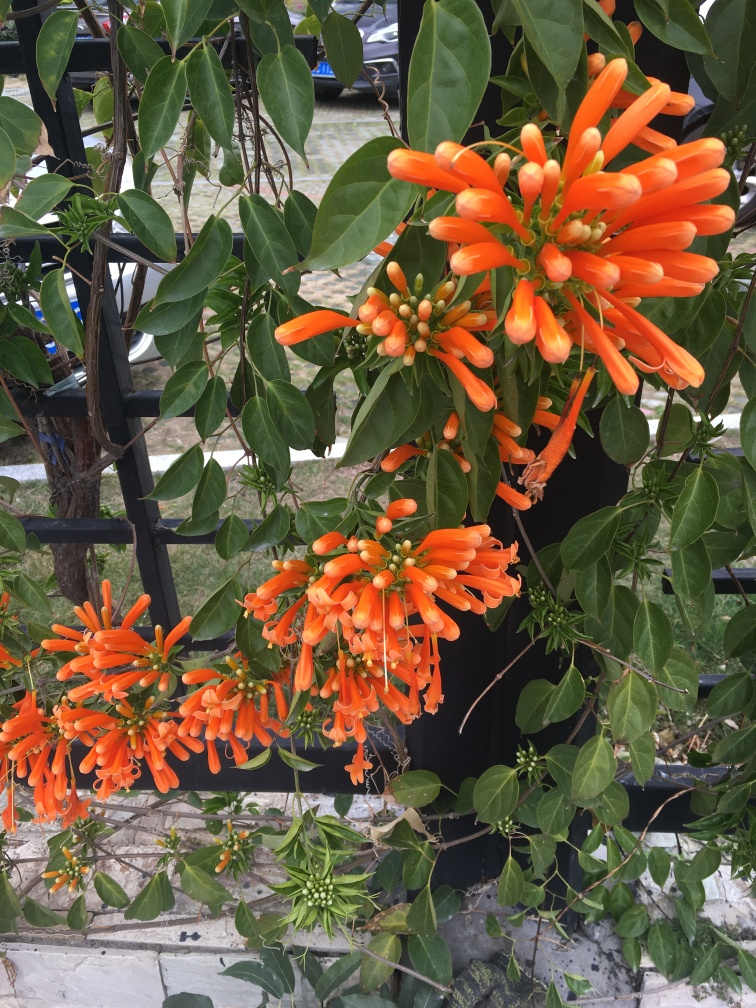Can you tell me what type of flowers these are? These appear to be Pyrostegia venusta, also known as flame vine or orange trumpet vine, which is known for its vivid orange flowers that grow in clusters. Are these flowers common in certain areas or climates? Yes, Pyrostegia venusta is commonly found in tropical and subtropical regions, thriving in warm climates and often used as ornamental plants due to their stunning floral displays. 